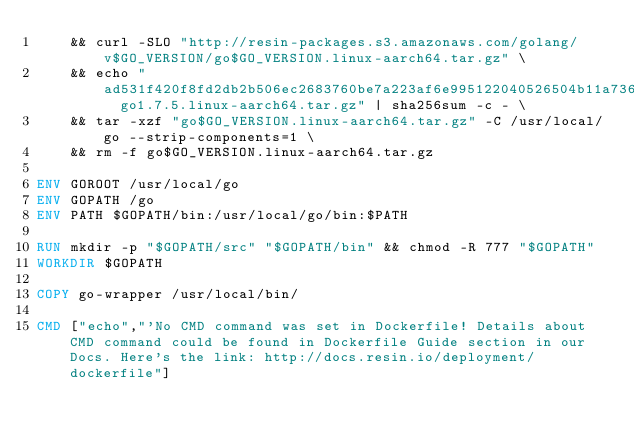<code> <loc_0><loc_0><loc_500><loc_500><_Dockerfile_>	&& curl -SLO "http://resin-packages.s3.amazonaws.com/golang/v$GO_VERSION/go$GO_VERSION.linux-aarch64.tar.gz" \
	&& echo "ad531f420f8fd2db2b506ec2683760be7a223af6e995122040526504b11a736c  go1.7.5.linux-aarch64.tar.gz" | sha256sum -c - \
	&& tar -xzf "go$GO_VERSION.linux-aarch64.tar.gz" -C /usr/local/go --strip-components=1 \
	&& rm -f go$GO_VERSION.linux-aarch64.tar.gz

ENV GOROOT /usr/local/go
ENV GOPATH /go
ENV PATH $GOPATH/bin:/usr/local/go/bin:$PATH

RUN mkdir -p "$GOPATH/src" "$GOPATH/bin" && chmod -R 777 "$GOPATH"
WORKDIR $GOPATH

COPY go-wrapper /usr/local/bin/

CMD ["echo","'No CMD command was set in Dockerfile! Details about CMD command could be found in Dockerfile Guide section in our Docs. Here's the link: http://docs.resin.io/deployment/dockerfile"]
</code> 